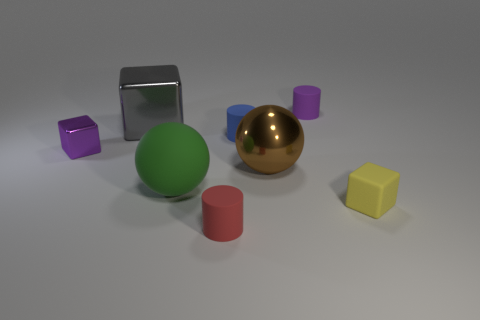Are there any big brown shiny cylinders?
Your answer should be compact. No. Is the shape of the small blue thing the same as the gray metal object?
Offer a very short reply. No. The cylinder that is the same color as the tiny metallic object is what size?
Provide a succinct answer. Small. There is a big brown shiny thing to the right of the red object; how many small cylinders are on the left side of it?
Offer a terse response. 2. What number of small rubber objects are behind the tiny metallic cube and in front of the small yellow thing?
Ensure brevity in your answer.  0. How many things are either big green balls or tiny matte things on the right side of the brown sphere?
Offer a terse response. 3. There is a sphere that is made of the same material as the large gray block; what size is it?
Offer a very short reply. Large. What is the shape of the large shiny object that is in front of the small purple object that is to the left of the gray metal cube?
Your answer should be compact. Sphere. What number of green things are either big metal spheres or tiny cubes?
Provide a short and direct response. 0. There is a big object behind the small block that is behind the rubber block; are there any rubber cylinders that are in front of it?
Your answer should be compact. Yes. 